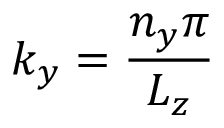<formula> <loc_0><loc_0><loc_500><loc_500>k _ { y } = \frac { n _ { y } \pi } { L _ { z } }</formula> 